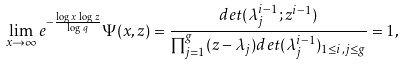Convert formula to latex. <formula><loc_0><loc_0><loc_500><loc_500>\lim _ { x \to \infty } e ^ { - \frac { \log \, x \, \log \, z } { \log \, q } } \Psi ( x , z ) = \frac { d e t ( \lambda _ { j } ^ { i - 1 } ; z ^ { i - 1 } ) } { \prod _ { j = 1 } ^ { g } ( z - \lambda _ { j } ) d e t ( \lambda _ { j } ^ { i - 1 } ) _ { 1 \leq i , j \leq g } } = 1 ,</formula> 